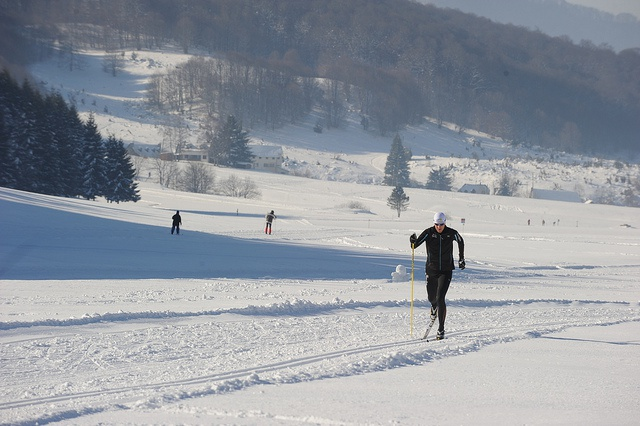Describe the objects in this image and their specific colors. I can see people in darkblue, black, gray, darkgray, and lightgray tones, people in darkblue, gray, darkgray, black, and lightgray tones, people in darkblue, black, navy, and gray tones, skis in darkblue, darkgray, lightgray, gray, and black tones, and people in darkgray, gray, and darkblue tones in this image. 